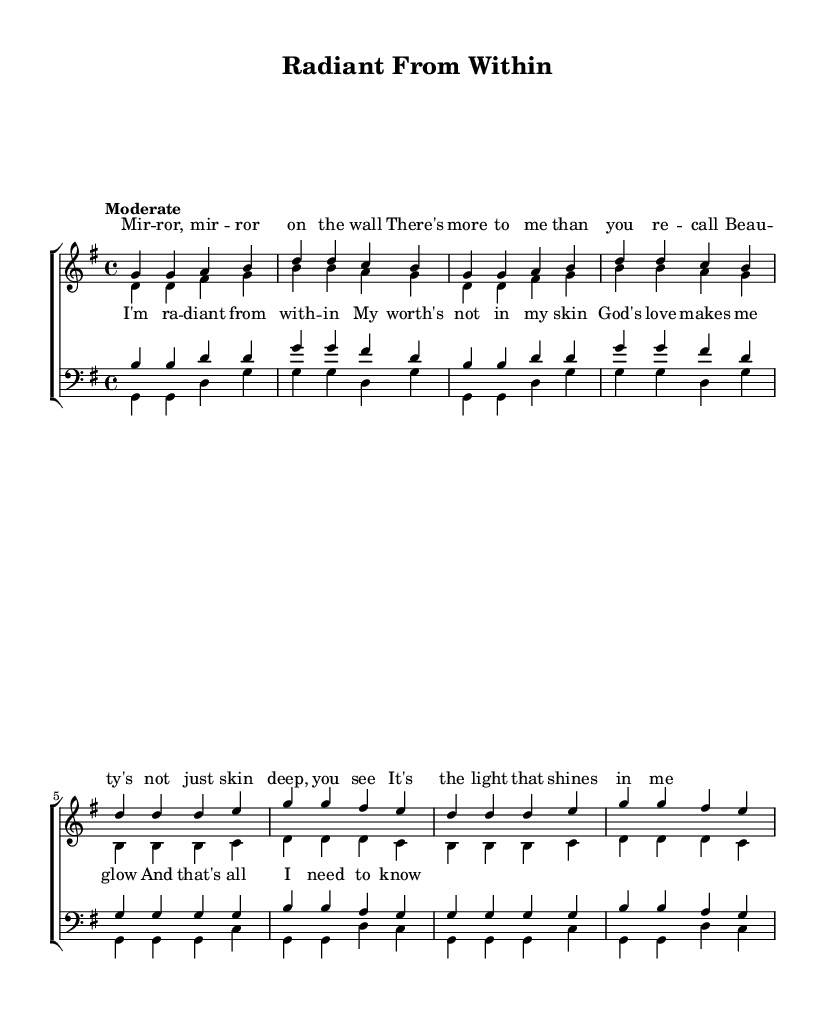What is the key signature of this music? The key signature is G major, which has one sharp (F#). This can be determined by examining the key signature mark at the beginning of the staff.
Answer: G major What is the time signature of this music? The time signature of the piece is 4/4, indicated at the beginning of the score. This means there are four beats in each measure and a quarter note receives one beat.
Answer: 4/4 What is the title of the piece? The title of the piece is "Radiant From Within," as indicated in the header section of the score.
Answer: Radiant From Within How many voices are in the choir arrangement? There are four distinct voices: sopranos, altos, tenors, and basses. This is noted in the structure of the score, which shows these voice parts separately.
Answer: Four What is the tempo marking of the piece? The tempo marking is "Moderate," which is noted above the score. This indicates the speed at which the piece should be performed.
Answer: Moderate What is the main theme of the lyrics? The main theme of the lyrics emphasizes inner beauty and self-worth, suggesting that true beauty comes from within rather than outward appearances. This can be inferred by analyzing the lyrics provided in the score.
Answer: Inner beauty Which section of the piece features the line "God's love makes me glow"? This line is part of the chorus lyrics. By looking at the lyrics section and their placement under the vocal parts, it can be identified as belonging to the chorus.
Answer: Chorus 